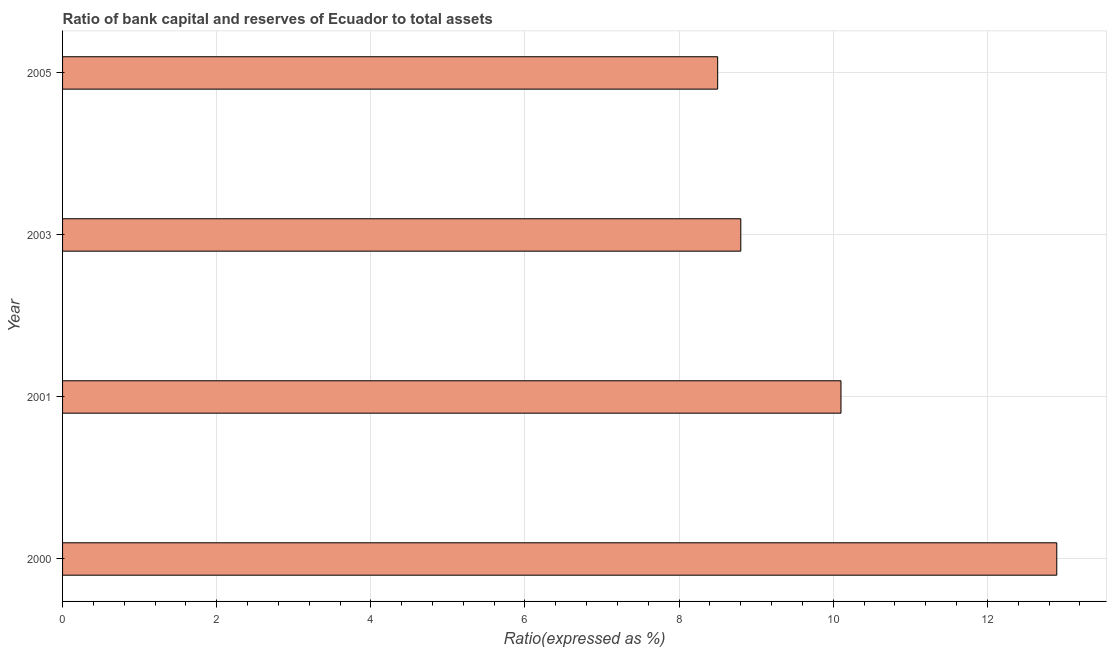Does the graph contain any zero values?
Your response must be concise. No. What is the title of the graph?
Your answer should be very brief. Ratio of bank capital and reserves of Ecuador to total assets. What is the label or title of the X-axis?
Provide a short and direct response. Ratio(expressed as %). What is the label or title of the Y-axis?
Your answer should be very brief. Year. Across all years, what is the maximum bank capital to assets ratio?
Ensure brevity in your answer.  12.9. What is the sum of the bank capital to assets ratio?
Give a very brief answer. 40.3. What is the difference between the bank capital to assets ratio in 2001 and 2005?
Ensure brevity in your answer.  1.6. What is the average bank capital to assets ratio per year?
Your answer should be very brief. 10.07. What is the median bank capital to assets ratio?
Offer a very short reply. 9.45. In how many years, is the bank capital to assets ratio greater than 10 %?
Offer a terse response. 2. What is the ratio of the bank capital to assets ratio in 2000 to that in 2001?
Make the answer very short. 1.28. Is the sum of the bank capital to assets ratio in 2000 and 2005 greater than the maximum bank capital to assets ratio across all years?
Your answer should be very brief. Yes. What is the difference between the highest and the lowest bank capital to assets ratio?
Keep it short and to the point. 4.4. How many bars are there?
Your answer should be compact. 4. Are all the bars in the graph horizontal?
Give a very brief answer. Yes. What is the difference between two consecutive major ticks on the X-axis?
Ensure brevity in your answer.  2. Are the values on the major ticks of X-axis written in scientific E-notation?
Provide a short and direct response. No. What is the Ratio(expressed as %) in 2000?
Make the answer very short. 12.9. What is the Ratio(expressed as %) of 2001?
Offer a very short reply. 10.1. What is the difference between the Ratio(expressed as %) in 2000 and 2001?
Offer a terse response. 2.8. What is the difference between the Ratio(expressed as %) in 2000 and 2003?
Your response must be concise. 4.1. What is the difference between the Ratio(expressed as %) in 2003 and 2005?
Give a very brief answer. 0.3. What is the ratio of the Ratio(expressed as %) in 2000 to that in 2001?
Your answer should be compact. 1.28. What is the ratio of the Ratio(expressed as %) in 2000 to that in 2003?
Give a very brief answer. 1.47. What is the ratio of the Ratio(expressed as %) in 2000 to that in 2005?
Provide a succinct answer. 1.52. What is the ratio of the Ratio(expressed as %) in 2001 to that in 2003?
Offer a terse response. 1.15. What is the ratio of the Ratio(expressed as %) in 2001 to that in 2005?
Provide a short and direct response. 1.19. What is the ratio of the Ratio(expressed as %) in 2003 to that in 2005?
Your answer should be very brief. 1.03. 